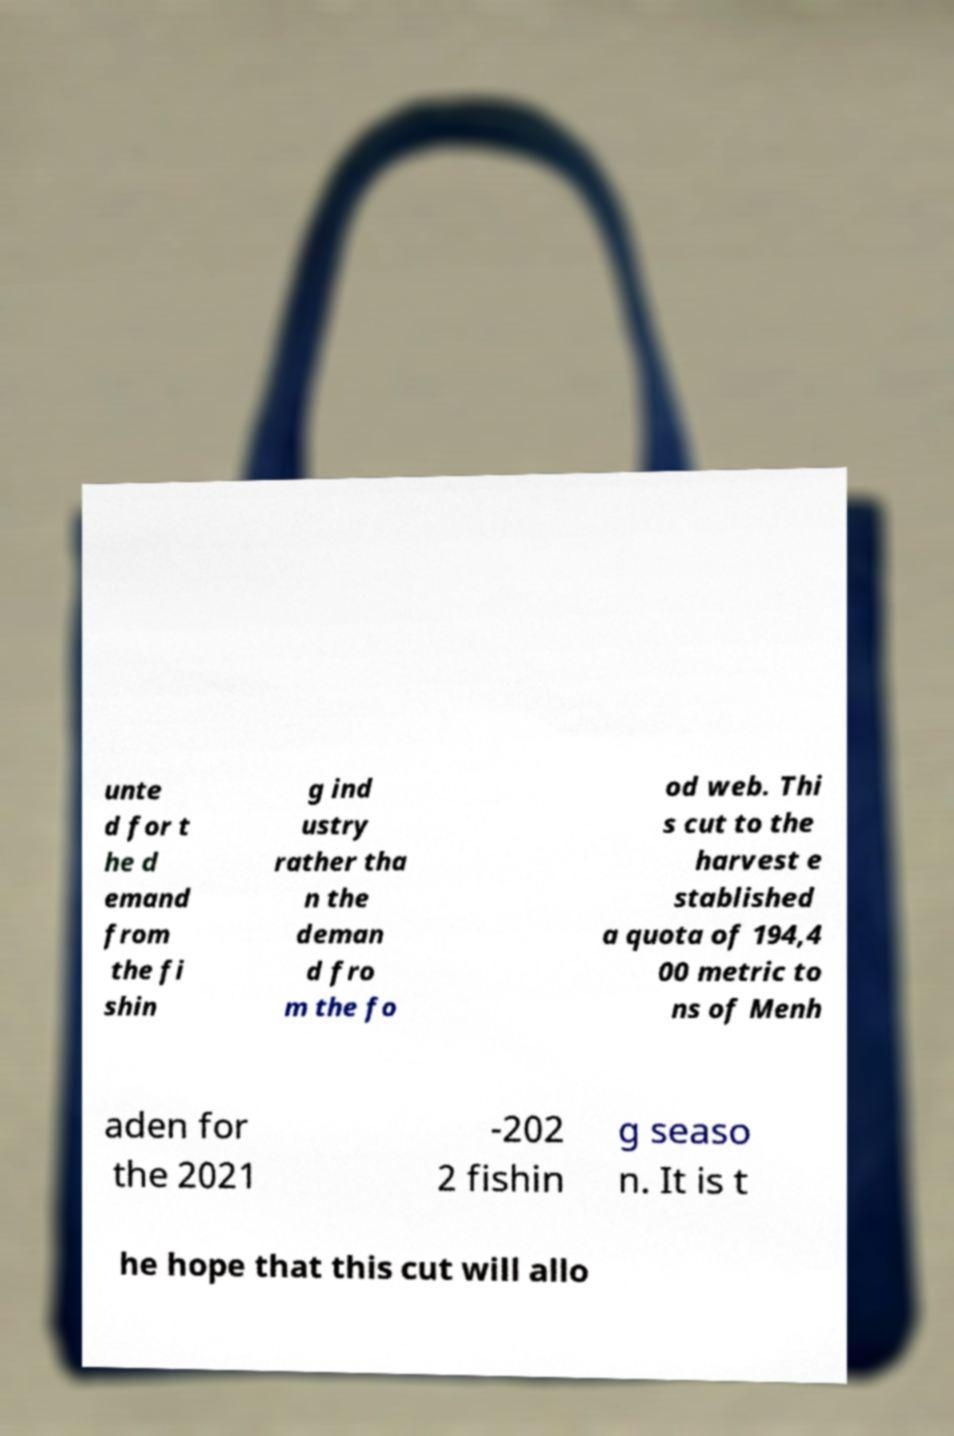Can you accurately transcribe the text from the provided image for me? unte d for t he d emand from the fi shin g ind ustry rather tha n the deman d fro m the fo od web. Thi s cut to the harvest e stablished a quota of 194,4 00 metric to ns of Menh aden for the 2021 -202 2 fishin g seaso n. It is t he hope that this cut will allo 